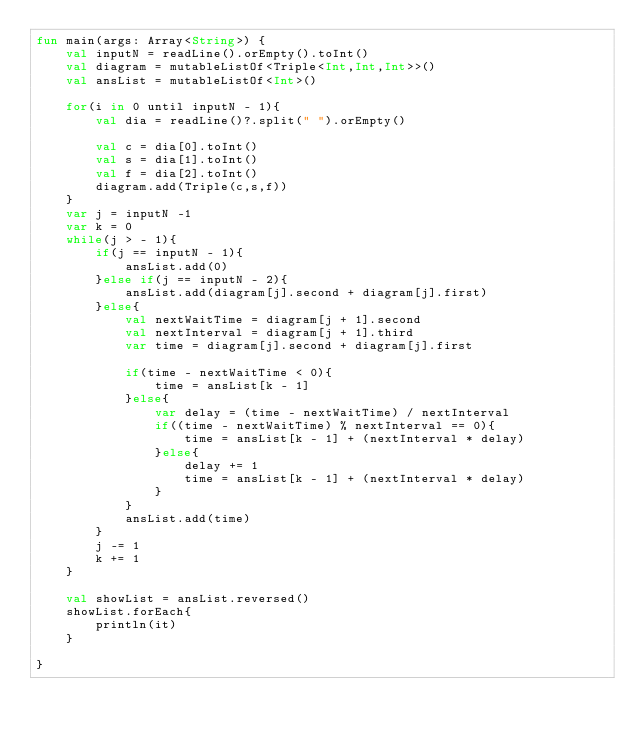<code> <loc_0><loc_0><loc_500><loc_500><_Kotlin_>fun main(args: Array<String>) {
    val inputN = readLine().orEmpty().toInt()
    val diagram = mutableListOf<Triple<Int,Int,Int>>()
    val ansList = mutableListOf<Int>()

    for(i in 0 until inputN - 1){
        val dia = readLine()?.split(" ").orEmpty()

        val c = dia[0].toInt()
        val s = dia[1].toInt()
        val f = dia[2].toInt()
        diagram.add(Triple(c,s,f))
    }
    var j = inputN -1
    var k = 0
    while(j > - 1){
        if(j == inputN - 1){
            ansList.add(0)
        }else if(j == inputN - 2){
            ansList.add(diagram[j].second + diagram[j].first)
        }else{
            val nextWaitTime = diagram[j + 1].second
            val nextInterval = diagram[j + 1].third
            var time = diagram[j].second + diagram[j].first

            if(time - nextWaitTime < 0){
                time = ansList[k - 1]
            }else{
                var delay = (time - nextWaitTime) / nextInterval
                if((time - nextWaitTime) % nextInterval == 0){
                    time = ansList[k - 1] + (nextInterval * delay)
                }else{
                    delay += 1
                    time = ansList[k - 1] + (nextInterval * delay)
                }
            }
            ansList.add(time)
        }
        j -= 1
        k += 1
    }

    val showList = ansList.reversed()
    showList.forEach{
        println(it)
    }

}</code> 